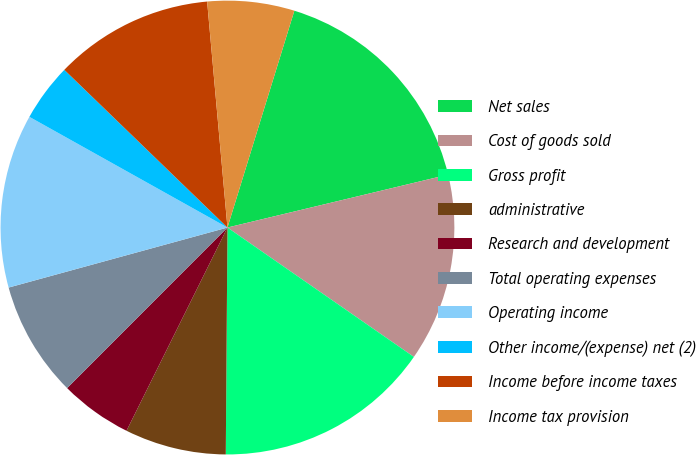<chart> <loc_0><loc_0><loc_500><loc_500><pie_chart><fcel>Net sales<fcel>Cost of goods sold<fcel>Gross profit<fcel>administrative<fcel>Research and development<fcel>Total operating expenses<fcel>Operating income<fcel>Other income/(expense) net (2)<fcel>Income before income taxes<fcel>Income tax provision<nl><fcel>16.49%<fcel>13.4%<fcel>15.46%<fcel>7.22%<fcel>5.15%<fcel>8.25%<fcel>12.37%<fcel>4.12%<fcel>11.34%<fcel>6.19%<nl></chart> 